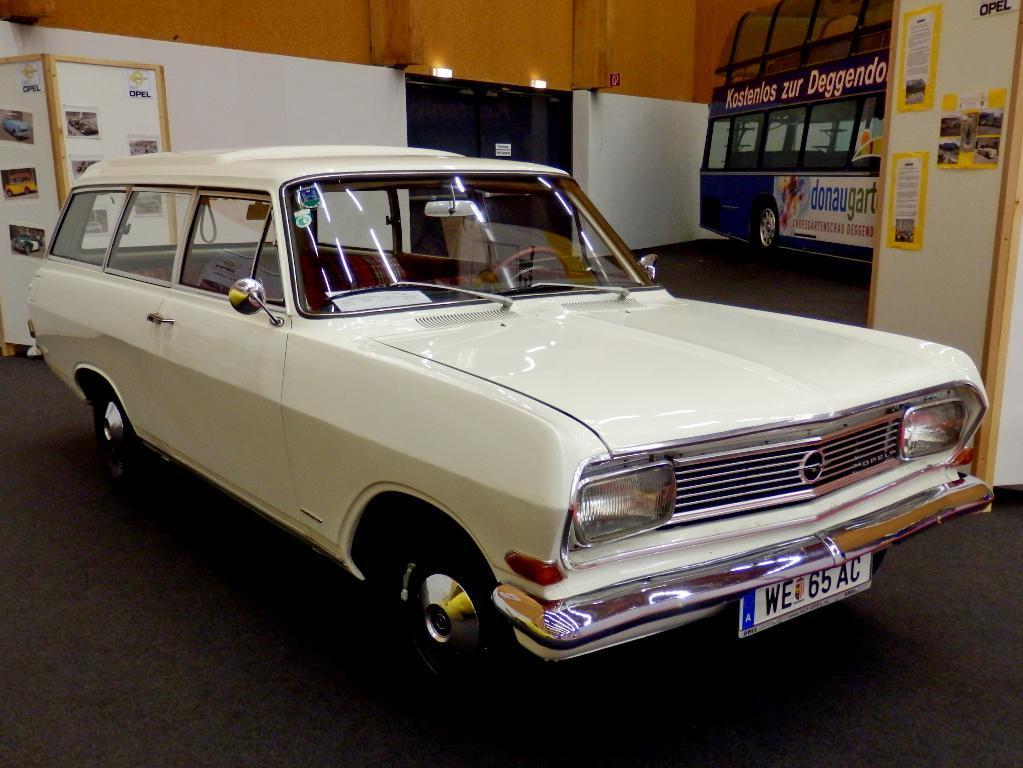How would you summarize this image in a sentence or two? In this image I can see the vehicles. To the right I can see some posts attached to the wooden board. I can also see few more photos and papers to the board in the back. I can see there is a white, black and brown color background. 